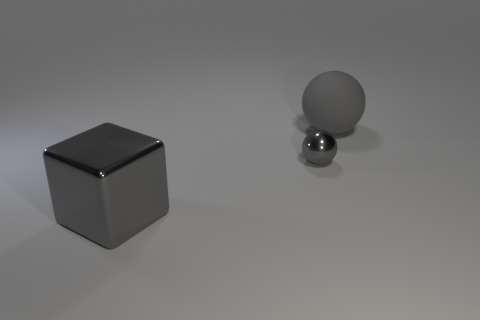What is the shape of the object that is in front of the large gray matte ball and behind the big block?
Ensure brevity in your answer.  Sphere. Do the gray rubber thing and the gray metal ball have the same size?
Give a very brief answer. No. What number of big gray objects are in front of the small metallic object?
Offer a terse response. 1. Are there an equal number of gray rubber balls that are in front of the metal cube and gray spheres in front of the matte thing?
Keep it short and to the point. No. There is a large object that is behind the small gray metallic object; is it the same shape as the small gray metal object?
Ensure brevity in your answer.  Yes. Are there any other things that are made of the same material as the large sphere?
Keep it short and to the point. No. Do the gray cube and the object that is behind the gray shiny ball have the same size?
Give a very brief answer. Yes. What number of other things are there of the same color as the rubber object?
Provide a succinct answer. 2. Are there any large gray metal cubes left of the matte thing?
Keep it short and to the point. Yes. How many objects are yellow cylinders or small gray balls that are in front of the rubber thing?
Ensure brevity in your answer.  1. 